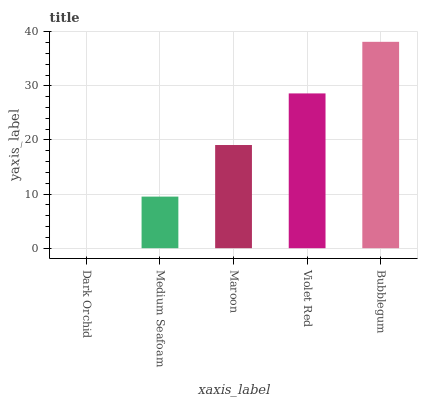Is Dark Orchid the minimum?
Answer yes or no. Yes. Is Bubblegum the maximum?
Answer yes or no. Yes. Is Medium Seafoam the minimum?
Answer yes or no. No. Is Medium Seafoam the maximum?
Answer yes or no. No. Is Medium Seafoam greater than Dark Orchid?
Answer yes or no. Yes. Is Dark Orchid less than Medium Seafoam?
Answer yes or no. Yes. Is Dark Orchid greater than Medium Seafoam?
Answer yes or no. No. Is Medium Seafoam less than Dark Orchid?
Answer yes or no. No. Is Maroon the high median?
Answer yes or no. Yes. Is Maroon the low median?
Answer yes or no. Yes. Is Violet Red the high median?
Answer yes or no. No. Is Bubblegum the low median?
Answer yes or no. No. 